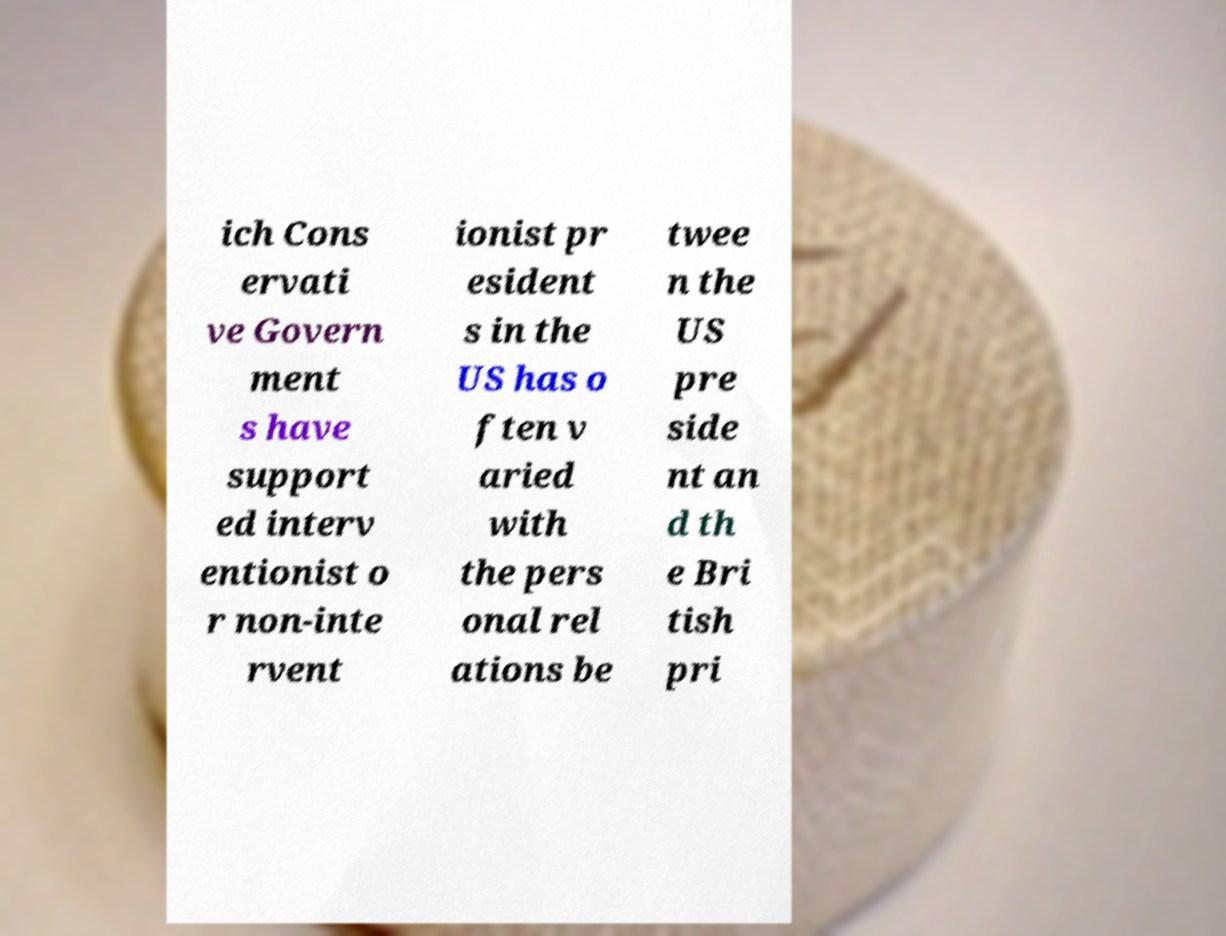Could you assist in decoding the text presented in this image and type it out clearly? ich Cons ervati ve Govern ment s have support ed interv entionist o r non-inte rvent ionist pr esident s in the US has o ften v aried with the pers onal rel ations be twee n the US pre side nt an d th e Bri tish pri 